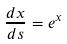<formula> <loc_0><loc_0><loc_500><loc_500>\frac { d x } { d s } = e ^ { x }</formula> 